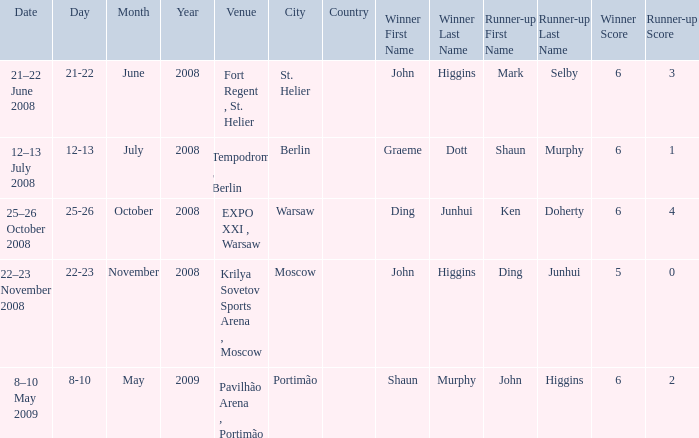When was the match that had Shaun Murphy as runner-up? 12–13 July 2008. 